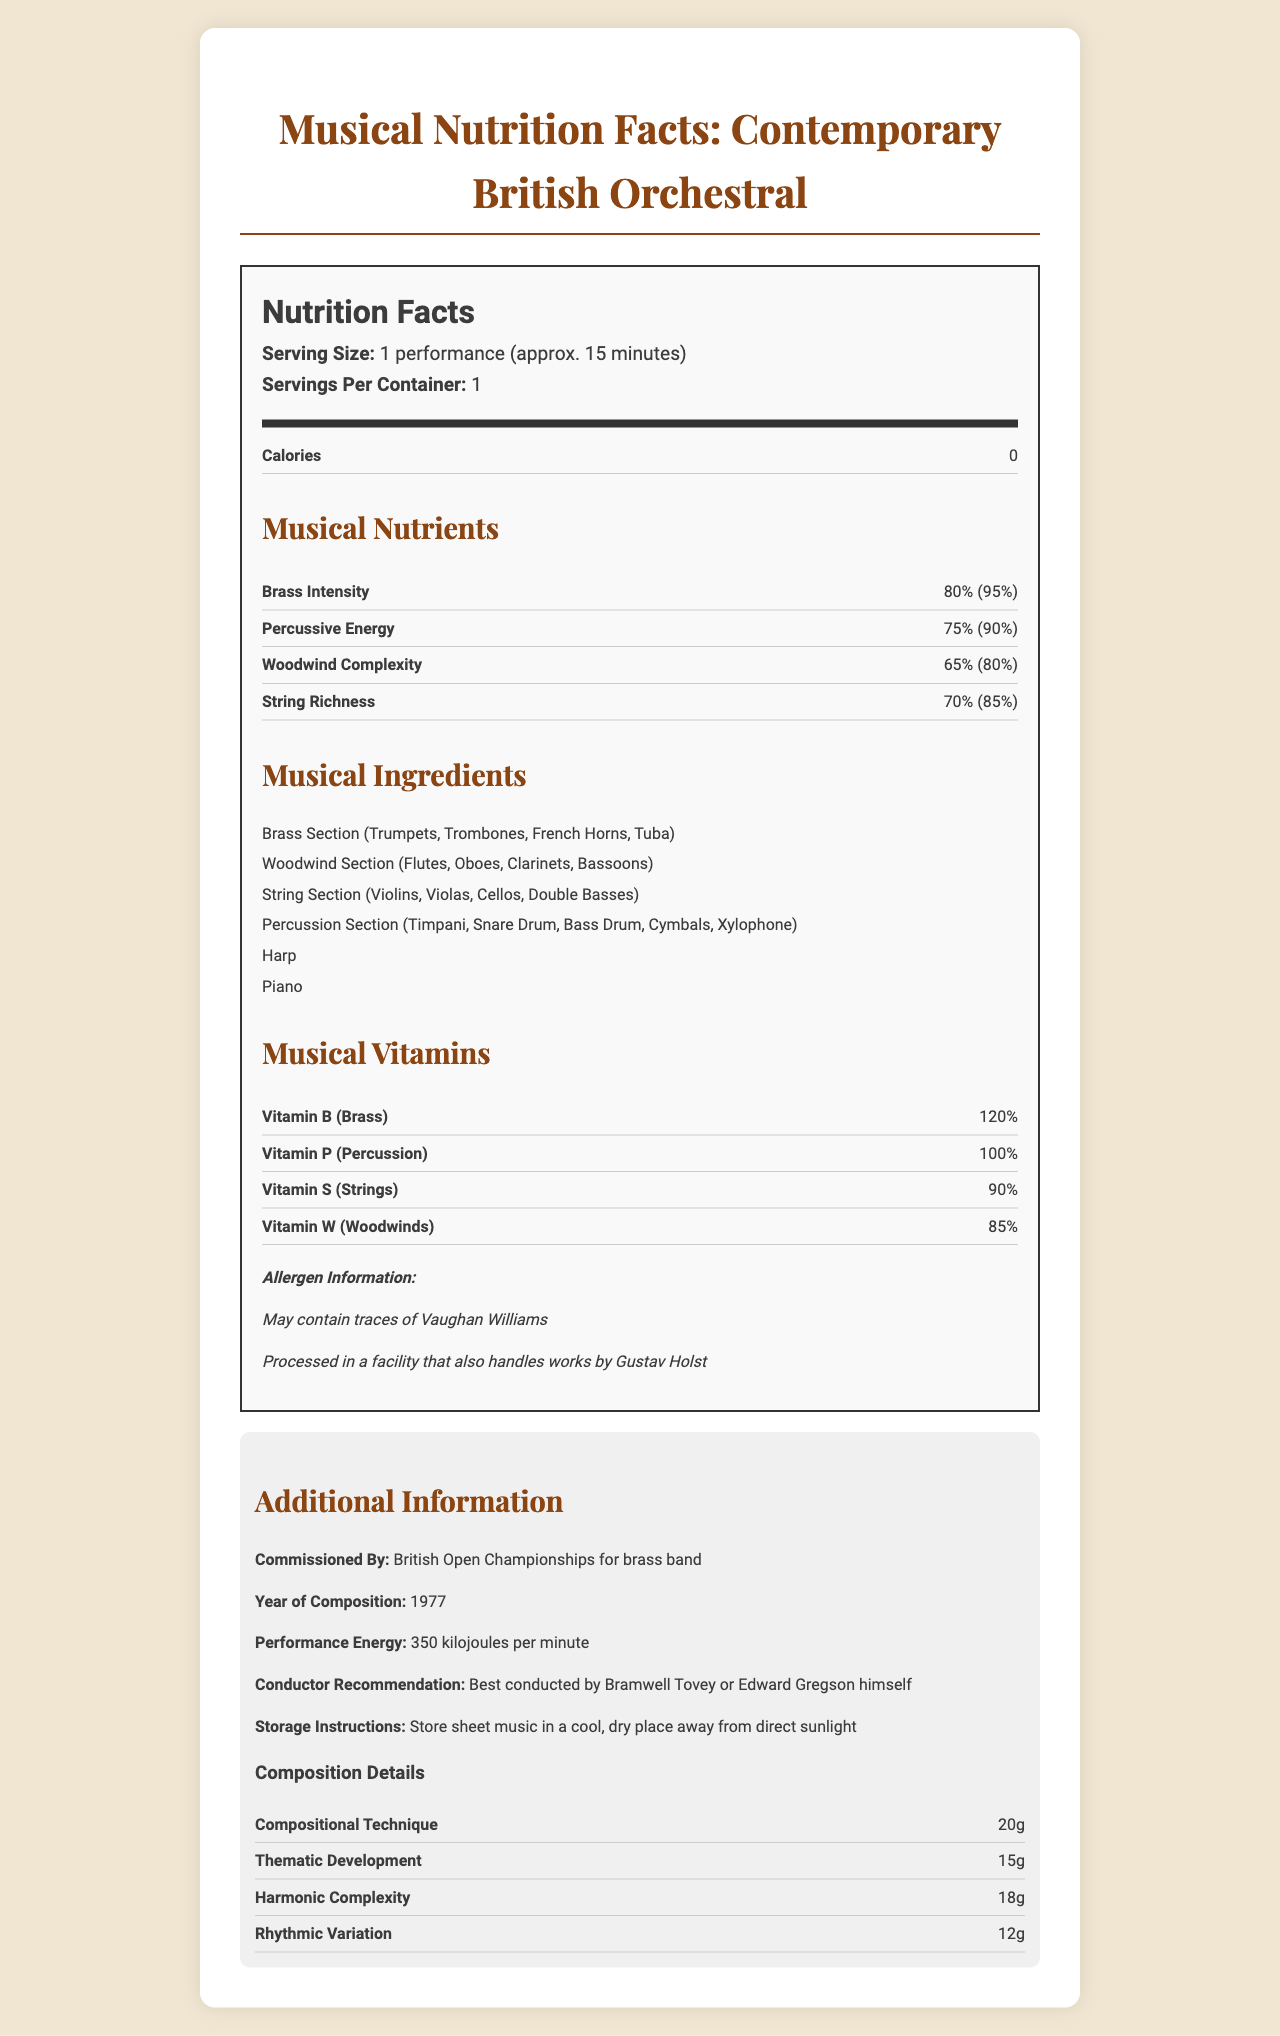what is the serving size for "Connotations"? The serving size is mentioned under the Nutrition Facts heading: "Serving Size: 1 performance (approx. 15 minutes)”.
Answer: 1 performance (approx. 15 minutes) how many servings per container are there? The "Servings Per Container" value is stated as "1" under the Nutrition Facts heading.
Answer: 1 how much Brass Intensity is there per serving? Under the Musical Nutrients section, Brass Intensity is listed as having an amount of 80%.
Answer: 80% what is the percentage of daily value for Woodwind Complexity? The document lists Woodwind Complexity with a daily value percentage of 80% under the Musical Nutrients section.
Answer: 80% list all the sections included under Musical Ingredients. The document lists six musical ingredients under the Musical Ingredients heading.
Answer: Brass Section (Trumpets, Trombones, French Horns, Tuba), Woodwind Section (Flutes, Oboes, Clarinets, Bassoons), String Section (Violins, Violas, Cellos, Double Basses), Percussion Section (Timpani, Snare Drum, Bass Drum, Cymbals, Xylophone), Harp, Piano what is the recommended conductor for "Connotations"? The Conductor Recommendation section advises Bramwell Tovey or Edward Gregson himself as the best conductors.
Answer: Bramwell Tovey or Edward Gregson himself who commissioned "Connotations"? Under the Additional Information section, it states that "Connotations" was commissioned by the British Open Championships for brass band.
Answer: British Open Championships for brass band what is the performance energy per minute of "Connotations"? A. 150 kilojoules B. 250 kilojoules C. 350 kilojoules D. 450 kilojoules The document states under Additional Information that the performance energy is 350 kilojoules per minute.
Answer: C which nutrient has the highest daily value percentage? A. Brass Intensity B. Percussive Energy C. Woodwind Complexity D. String Richness Brass Intensity has the highest daily value percentage of 95% as listed under the Musical Nutrients section.
Answer: A is this work suggested to be conducted by Vaughan Williams? The Conductor Recommendation section specifically suggests Bramwell Tovey or Edward Gregson himself, not Vaughan Williams.
Answer: No does "Connotations" contain any elements of rhythmic variation? The Additional Information section under Composition Details lists Rhythmic Variation with a value of 12g.
Answer: Yes what are the storage instructions for the sheet music of "Connotations"? The Additional Information section provides these storage instructions directly.
Answer: Store sheet music in a cool, dry place away from direct sunlight how much thematic development is noted in the composition details? The value for Thematic Development is listed as 15g under the Composition Details section in Additional Information.
Answer: 15g summarize the main idea of the Nutrition Facts Label for "Connotations". This summary encapsulates the entire document's primary details and its creative approach, presenting musical aspects as nutritional elements.
Answer: The document is a creative representation of nutritional facts for Edward Gregson's orchestral work "Connotations". It includes serving size, servings per container, calories, and a detailed breakdown of musical nutrients, vitamins, ingredients, and additional compositional details. It also offers conductor recommendations, storage instructions, and information about the performance energy. for whom is the nutritional information about "Connotations" beneficial? The document does not specify a target audience or beneficiary for this nutritional information.
Answer: Not enough information is Harmonic Complexity listed as a musical vitamin? Harmonic Complexity is listed under Additional Information in the Composition Details section, not under Musical Vitamins.
Answer: No 